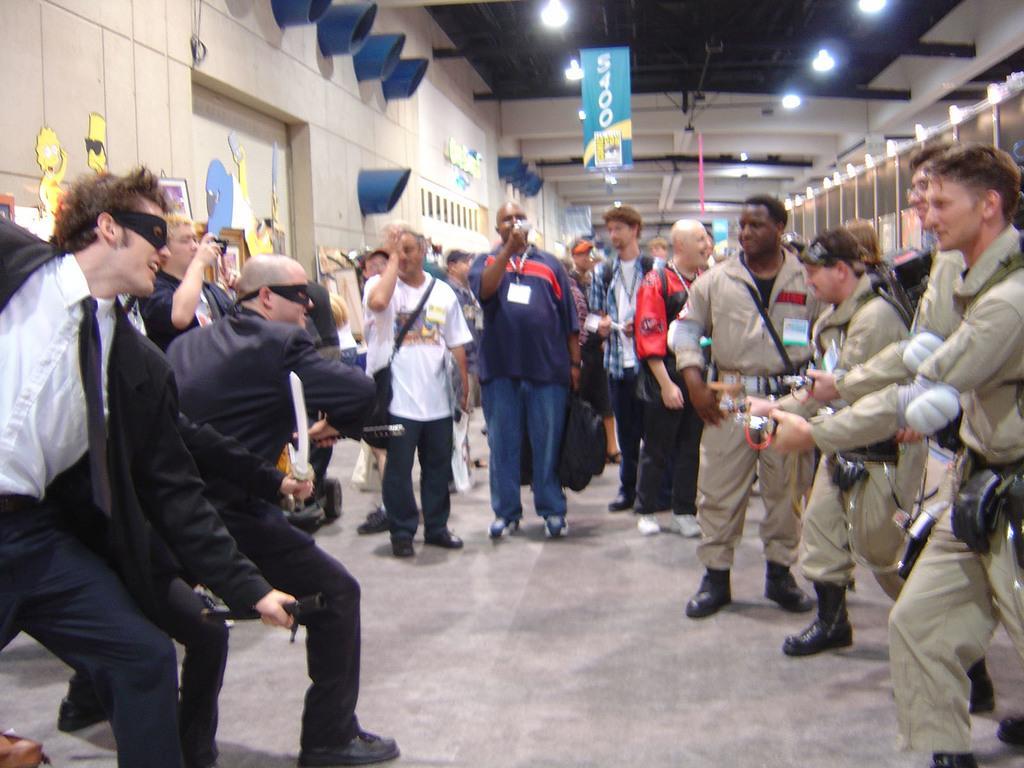Could you give a brief overview of what you see in this image? In this picture, we see people standing. On the right side, we see men in uniform are standing. Behind them, we see racks. On the left side, we see people standing. Behind that, we see a wall on which many posters are pasted. At the top of the picture, we see the ceiling of the room. 